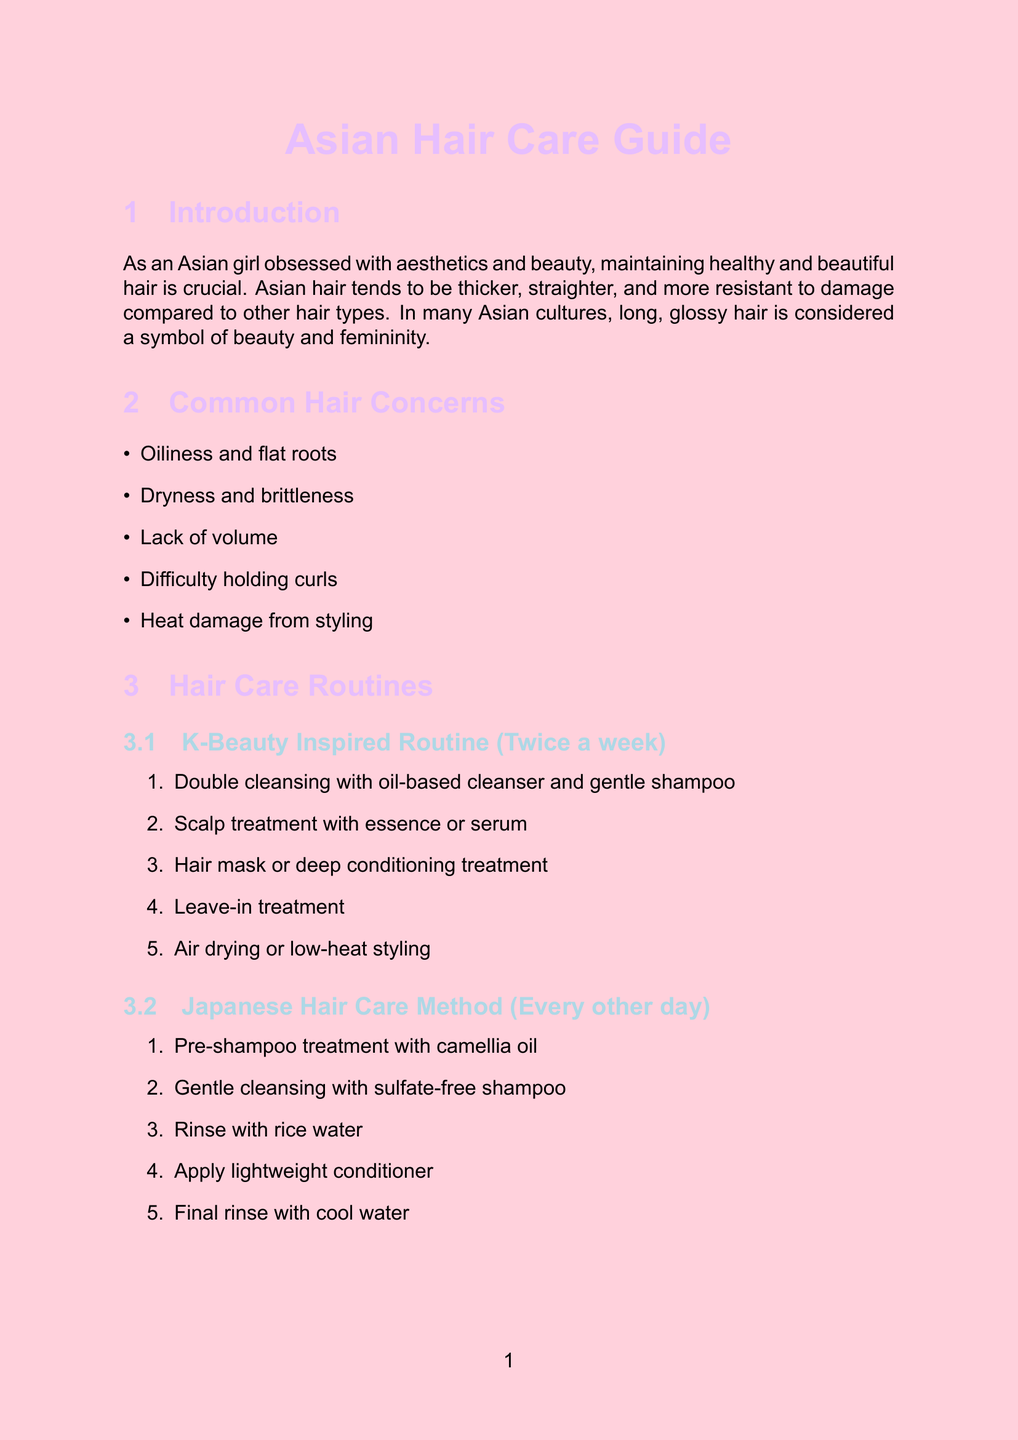What are the unique characteristics of Asian hair? The document states that Asian hair tends to be thicker, straighter, and more resistant to damage compared to other hair types.
Answer: Thicker, straighter, and more resistant to damage How often should the K-Beauty Inspired Routine be followed? The document specifies that the K-Beauty Inspired Routine should be followed twice a week.
Answer: Twice a week What are the benefits of using Olaplex No. 3 Hair Perfector? The benefits listed for Olaplex No. 3 Hair Perfector in the document include repairs bonds and strengthens hair structure.
Answer: Repairs bonds, strengthens hair structure What type of oil is used in the pre-shampoo treatment of the Japanese Hair Care Method? The document mentions that the pre-shampoo treatment includes camellia oil.
Answer: Camellia oil What is one of the common hair concerns mentioned in the document? It lists oiliness and flat roots as one of the common hair concerns.
Answer: Oiliness and flat roots How should the rice water rinse be prepared? The document states to soak rice in water, strain, and use as a final rinse.
Answer: Soak rice in water, strain, and use as a final rinse What is the frequency of the Ayurvedic Hair Care Ritual? According to the document, the Ayurvedic Hair Care Ritual should be done once a week.
Answer: Once a week What key ingredient is in the Klorane Shampoo with Peony? The document lists peony extract as the key ingredient in Klorane Shampoo with Peony.
Answer: Peony extract 